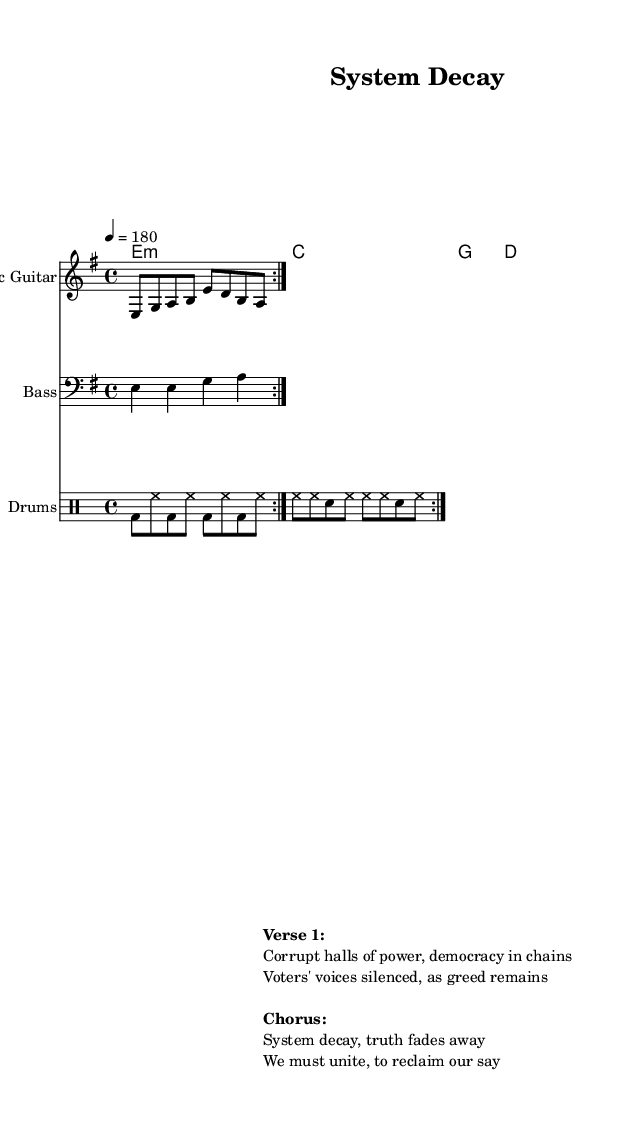What is the key signature of this music? The key signature is E minor, which is indicated at the beginning of the score. E minor has one sharp (F#).
Answer: E minor What is the time signature of this piece? The time signature is 4/4, which means there are four beats in a measure and the quarter note gets one beat. This is visible right at the beginning of the score.
Answer: 4/4 What is the tempo marking for this music? The tempo marking is 180 beats per minute, indicated by the number 4 = 180 at the start of the score. This shows that the piece is quite fast.
Answer: 180 How many measures are repeated in the electric guitar part? The electric guitar part has a section that is repeated twice, which is indicated by the repeat volta markings. This adds to the driving intensity typical in thrash metal.
Answer: 2 What theme is addressed in the lyrics of this song? The lyrics critique corruption in government systems, highlighting issues like silenced voters and greed, which is a common theme in thrash metal addressing social issues.
Answer: Corruption What type of drum patterns are used in this piece? The drum part features a standard combination of bass drum (bd), hi-hat (hh), and snare (sn), typical in fast-paced metal music, characterized by rapid rhythmic patterns.
Answer: Fast-paced patterns What is the vocal style suggested by the lyrics? The lyrics suggest a passionate and aggressive vocal delivery, typical of thrash metal, as they convey urgency and a call to action against systemic corruption.
Answer: Aggressive 